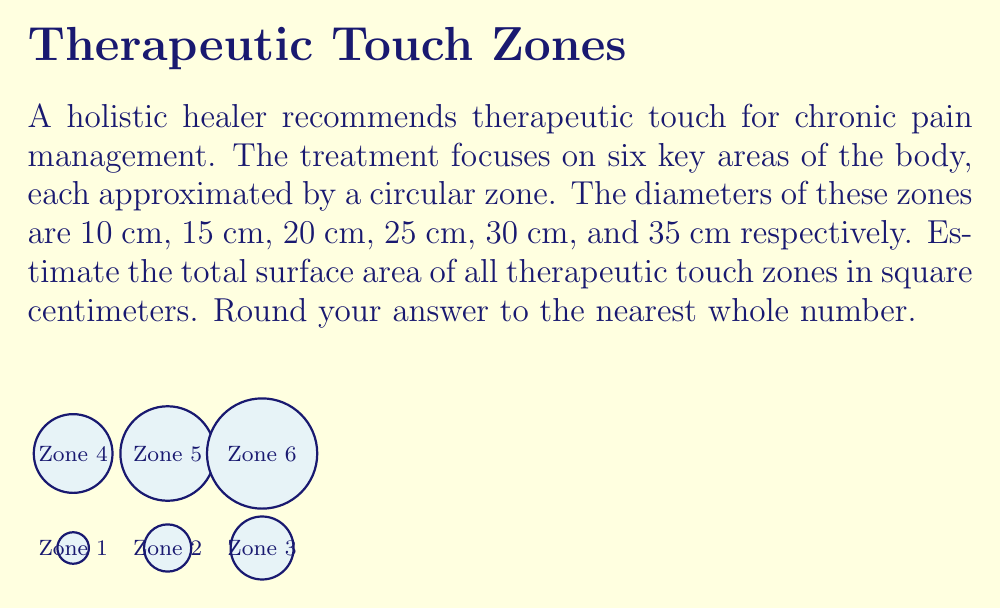Help me with this question. To solve this problem, we'll follow these steps:

1) The formula for the area of a circle is $A = \pi r^2$, where $r$ is the radius.

2) We're given diameters, so we need to divide each by 2 to get the radius.

3) Let's calculate the area of each zone:

   Zone 1: $r = 5$ cm
   $A_1 = \pi (5)^2 = 25\pi$ cm²

   Zone 2: $r = 7.5$ cm
   $A_2 = \pi (7.5)^2 = 56.25\pi$ cm²

   Zone 3: $r = 10$ cm
   $A_3 = \pi (10)^2 = 100\pi$ cm²

   Zone 4: $r = 12.5$ cm
   $A_4 = \pi (12.5)^2 = 156.25\pi$ cm²

   Zone 5: $r = 15$ cm
   $A_5 = \pi (15)^2 = 225\pi$ cm²

   Zone 6: $r = 17.5$ cm
   $A_6 = \pi (17.5)^2 = 306.25\pi$ cm²

4) Sum up all the areas:

   $A_{total} = (25 + 56.25 + 100 + 156.25 + 225 + 306.25)\pi$
              $= 868.75\pi$ cm²

5) Multiply by $\pi \approx 3.14159$:

   $A_{total} \approx 868.75 \times 3.14159 \approx 2729.33$ cm²

6) Rounding to the nearest whole number:

   $A_{total} \approx 2729$ cm²
Answer: 2729 cm² 